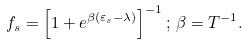<formula> <loc_0><loc_0><loc_500><loc_500>f _ { s } = \left [ 1 + e ^ { \beta ( \varepsilon _ { s } - \lambda ) } \right ] ^ { - 1 } ; \, \beta = T ^ { - 1 } .</formula> 